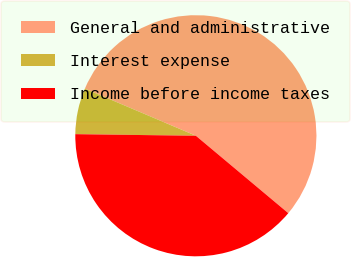<chart> <loc_0><loc_0><loc_500><loc_500><pie_chart><fcel>General and administrative<fcel>Interest expense<fcel>Income before income taxes<nl><fcel>54.7%<fcel>6.18%<fcel>39.11%<nl></chart> 